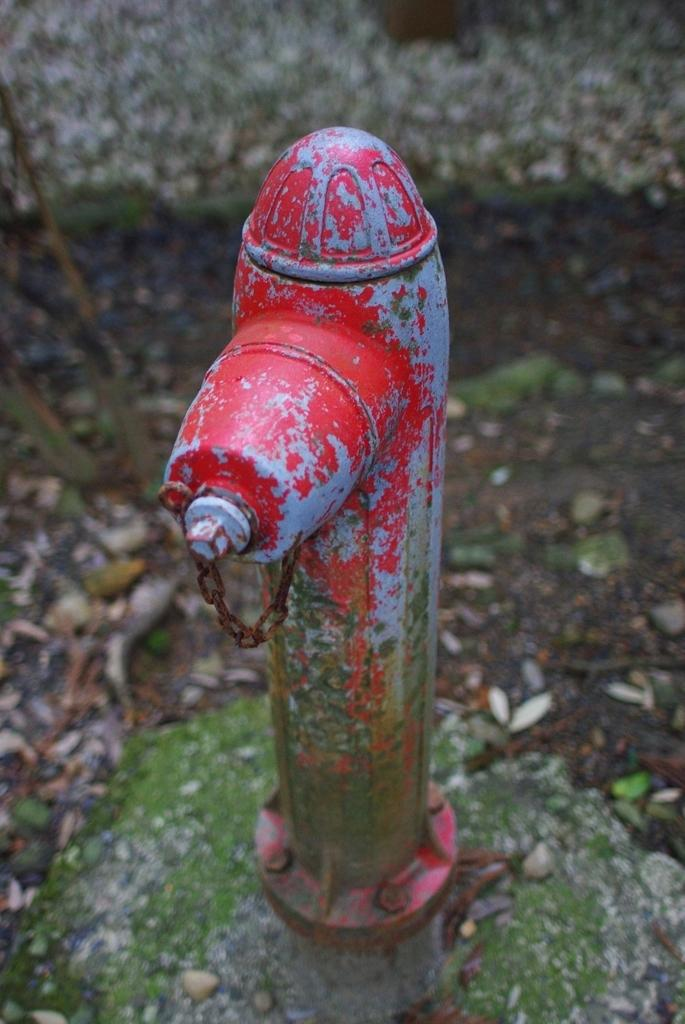What is the main object in the image? There is a water pipe in the image. What is the cause of death for the thing in the image? There is no death or thing present in the image, as it only features a water pipe. 